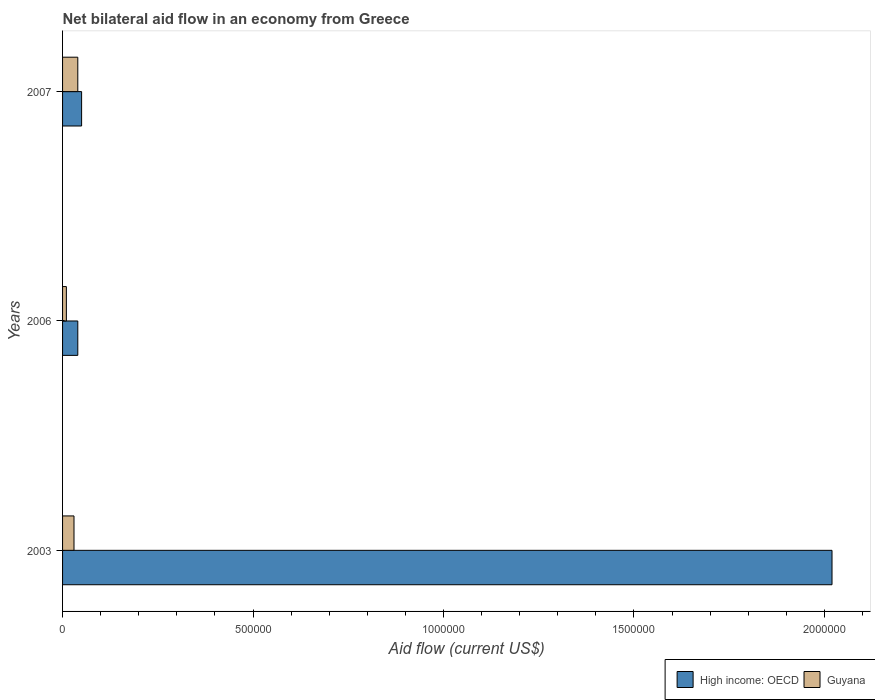How many different coloured bars are there?
Ensure brevity in your answer.  2. How many groups of bars are there?
Make the answer very short. 3. Are the number of bars per tick equal to the number of legend labels?
Offer a terse response. Yes. What is the label of the 1st group of bars from the top?
Offer a very short reply. 2007. Across all years, what is the minimum net bilateral aid flow in High income: OECD?
Keep it short and to the point. 4.00e+04. In which year was the net bilateral aid flow in High income: OECD minimum?
Make the answer very short. 2006. What is the total net bilateral aid flow in High income: OECD in the graph?
Make the answer very short. 2.11e+06. What is the difference between the net bilateral aid flow in Guyana in 2003 and that in 2006?
Your answer should be compact. 2.00e+04. What is the difference between the net bilateral aid flow in Guyana in 2007 and the net bilateral aid flow in High income: OECD in 2003?
Offer a terse response. -1.98e+06. What is the average net bilateral aid flow in High income: OECD per year?
Ensure brevity in your answer.  7.03e+05. In how many years, is the net bilateral aid flow in Guyana greater than 500000 US$?
Offer a very short reply. 0. What is the ratio of the net bilateral aid flow in High income: OECD in 2003 to that in 2006?
Make the answer very short. 50.5. Is the net bilateral aid flow in High income: OECD in 2003 less than that in 2006?
Your response must be concise. No. What is the difference between the highest and the second highest net bilateral aid flow in High income: OECD?
Offer a very short reply. 1.97e+06. What does the 1st bar from the top in 2003 represents?
Ensure brevity in your answer.  Guyana. What does the 2nd bar from the bottom in 2006 represents?
Make the answer very short. Guyana. How many years are there in the graph?
Your response must be concise. 3. Are the values on the major ticks of X-axis written in scientific E-notation?
Provide a short and direct response. No. Does the graph contain any zero values?
Your response must be concise. No. How many legend labels are there?
Offer a very short reply. 2. What is the title of the graph?
Provide a short and direct response. Net bilateral aid flow in an economy from Greece. What is the Aid flow (current US$) in High income: OECD in 2003?
Give a very brief answer. 2.02e+06. What is the Aid flow (current US$) in Guyana in 2006?
Your answer should be very brief. 10000. What is the Aid flow (current US$) in High income: OECD in 2007?
Provide a succinct answer. 5.00e+04. What is the Aid flow (current US$) of Guyana in 2007?
Make the answer very short. 4.00e+04. Across all years, what is the maximum Aid flow (current US$) of High income: OECD?
Offer a very short reply. 2.02e+06. Across all years, what is the minimum Aid flow (current US$) of High income: OECD?
Your answer should be very brief. 4.00e+04. Across all years, what is the minimum Aid flow (current US$) of Guyana?
Offer a terse response. 10000. What is the total Aid flow (current US$) of High income: OECD in the graph?
Your answer should be compact. 2.11e+06. What is the difference between the Aid flow (current US$) in High income: OECD in 2003 and that in 2006?
Provide a short and direct response. 1.98e+06. What is the difference between the Aid flow (current US$) in High income: OECD in 2003 and that in 2007?
Your response must be concise. 1.97e+06. What is the difference between the Aid flow (current US$) of Guyana in 2003 and that in 2007?
Make the answer very short. -10000. What is the difference between the Aid flow (current US$) of High income: OECD in 2006 and that in 2007?
Ensure brevity in your answer.  -10000. What is the difference between the Aid flow (current US$) of High income: OECD in 2003 and the Aid flow (current US$) of Guyana in 2006?
Offer a very short reply. 2.01e+06. What is the difference between the Aid flow (current US$) in High income: OECD in 2003 and the Aid flow (current US$) in Guyana in 2007?
Make the answer very short. 1.98e+06. What is the average Aid flow (current US$) of High income: OECD per year?
Give a very brief answer. 7.03e+05. What is the average Aid flow (current US$) of Guyana per year?
Provide a succinct answer. 2.67e+04. In the year 2003, what is the difference between the Aid flow (current US$) of High income: OECD and Aid flow (current US$) of Guyana?
Your answer should be compact. 1.99e+06. What is the ratio of the Aid flow (current US$) in High income: OECD in 2003 to that in 2006?
Give a very brief answer. 50.5. What is the ratio of the Aid flow (current US$) of Guyana in 2003 to that in 2006?
Make the answer very short. 3. What is the ratio of the Aid flow (current US$) of High income: OECD in 2003 to that in 2007?
Provide a short and direct response. 40.4. What is the difference between the highest and the second highest Aid flow (current US$) in High income: OECD?
Offer a terse response. 1.97e+06. What is the difference between the highest and the lowest Aid flow (current US$) of High income: OECD?
Provide a short and direct response. 1.98e+06. 